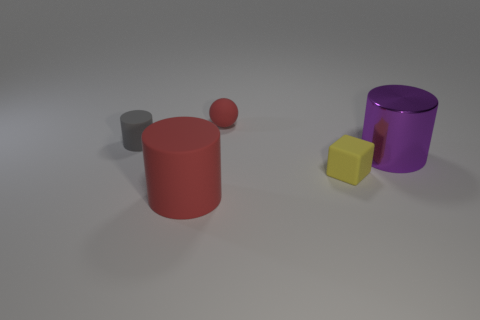What colors are the objects in the image, and how many objects of each color are there? In the image, we have a variety of colors. There is one red cylinder, one gray cylinder and one smaller gray sphere, one purple cylinder, and one yellow cube. So, that makes it one object each for red, purple, and yellow, and two for gray. 